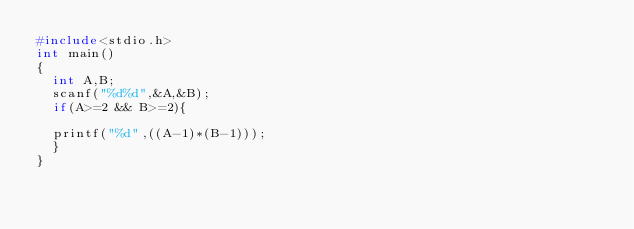Convert code to text. <code><loc_0><loc_0><loc_500><loc_500><_C_>#include<stdio.h>
int main()
{
	int A,B;
	scanf("%d%d",&A,&B);
	if(A>=2 && B>=2){
	
	printf("%d",((A-1)*(B-1)));
	}	
}
	</code> 